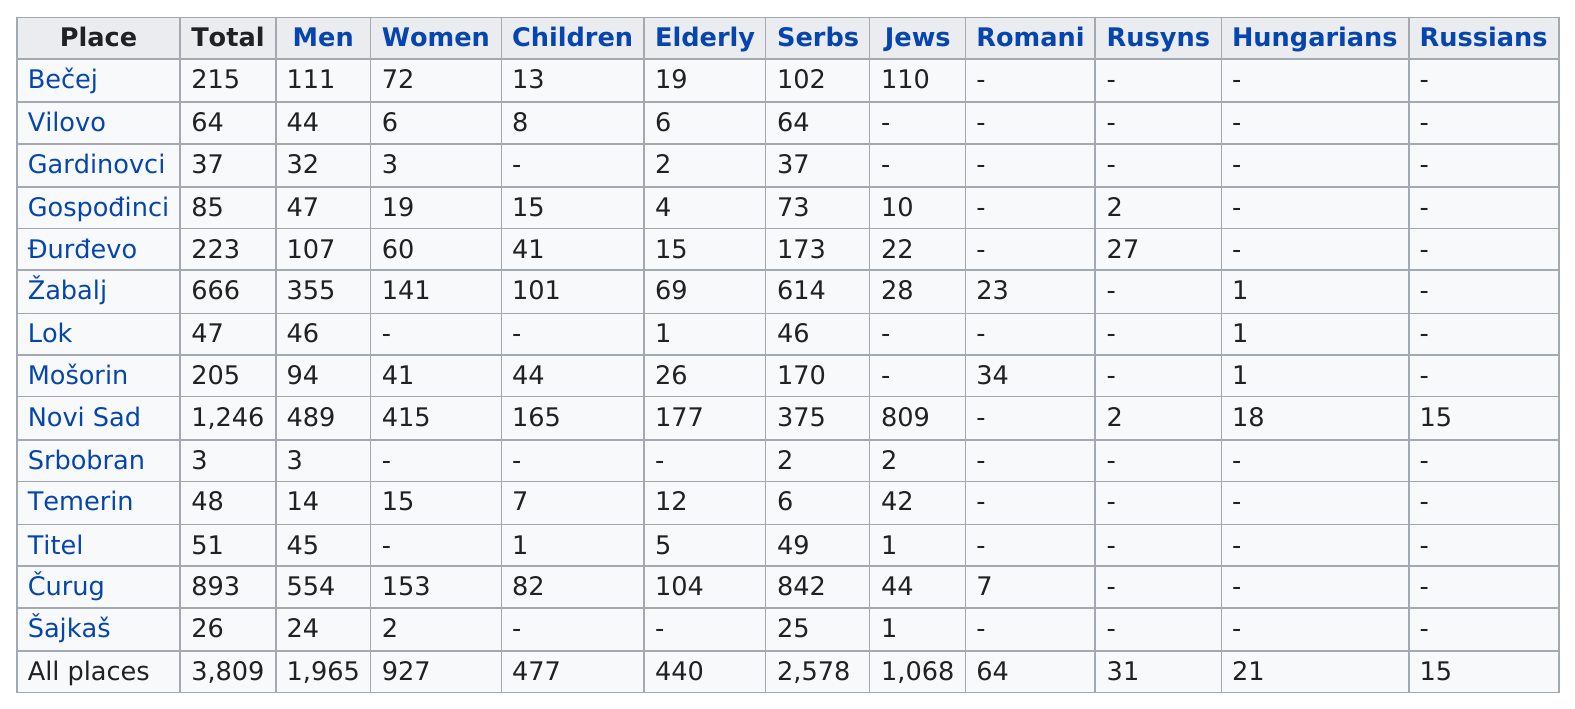Give some essential details in this illustration. On average, 272 victims were affected by all places in the study. There were a total of 8 child casualties in Temerin and Titl. Novi Sad was the top city for victims of a certain event or phenomenon. The total number of victims in Becej was 215. There was only one elderly casualty at the location referred to as Lok. 